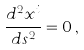Convert formula to latex. <formula><loc_0><loc_0><loc_500><loc_500>\frac { d ^ { 2 } x ^ { i } } { d s ^ { 2 } } = 0 \, ,</formula> 